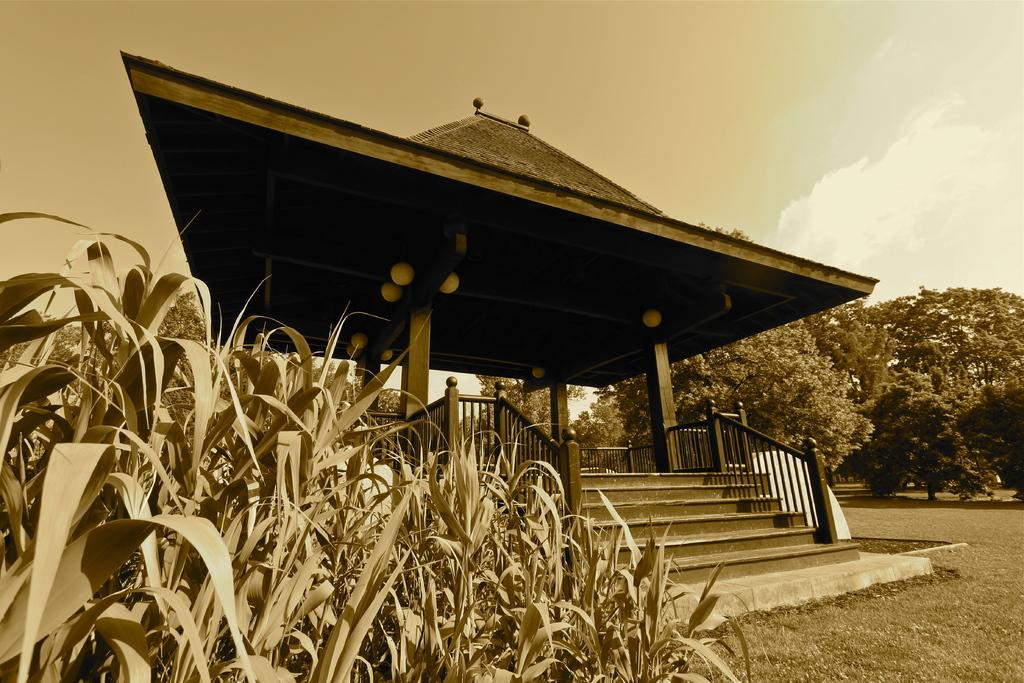What is the color scheme of the image? The image is black and white. What can be seen at the top of the image? The sky is visible at the top of the image. What structure is located in the middle of the image? There is a roof in the middle of the image. What architectural feature is present in the image? A staircase is present in the image. What type of vegetation is visible in the image? Trees and grass are visible in the image. Where is the basketball located in the image? There is no basketball present in the image. What word is written on the roof in the image? There are no words visible on the roof in the image. What type of oven can be seen in the image? There is no oven present in the image. 